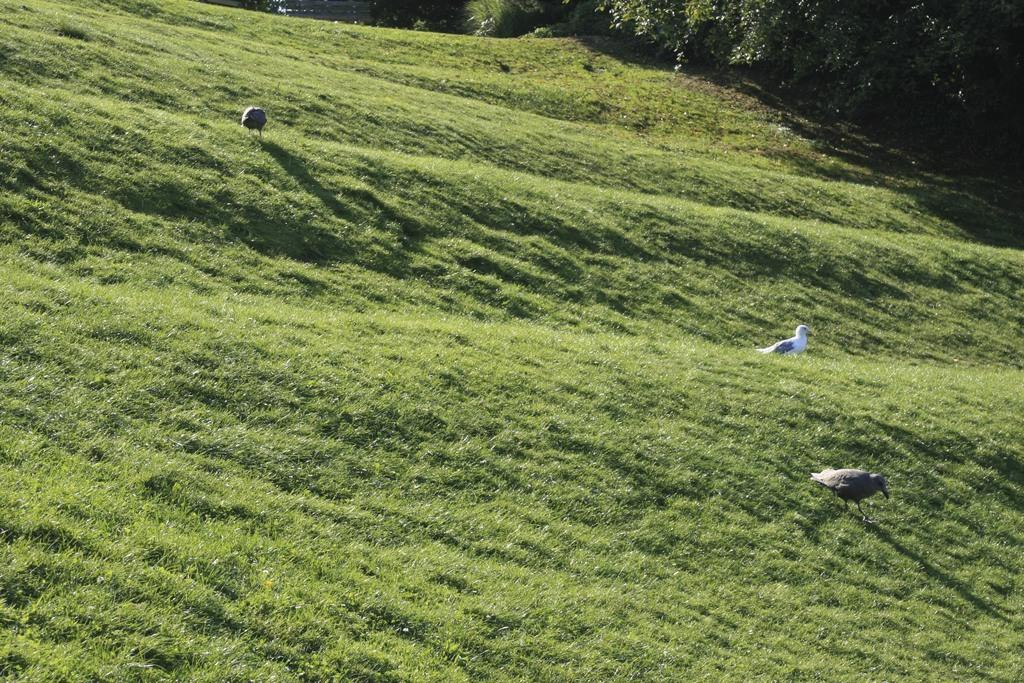What type of animals can be seen on the ground in the image? There are birds on the ground in the image. What type of vegetation is present in the image? There are trees and grass in the image. What type of string can be seen tied around the birds' wings in the image? There is no string tied around the birds' wings in the image. How many fingers are visible on the birds in the image? Birds do not have fingers, and none are visible in the image. 